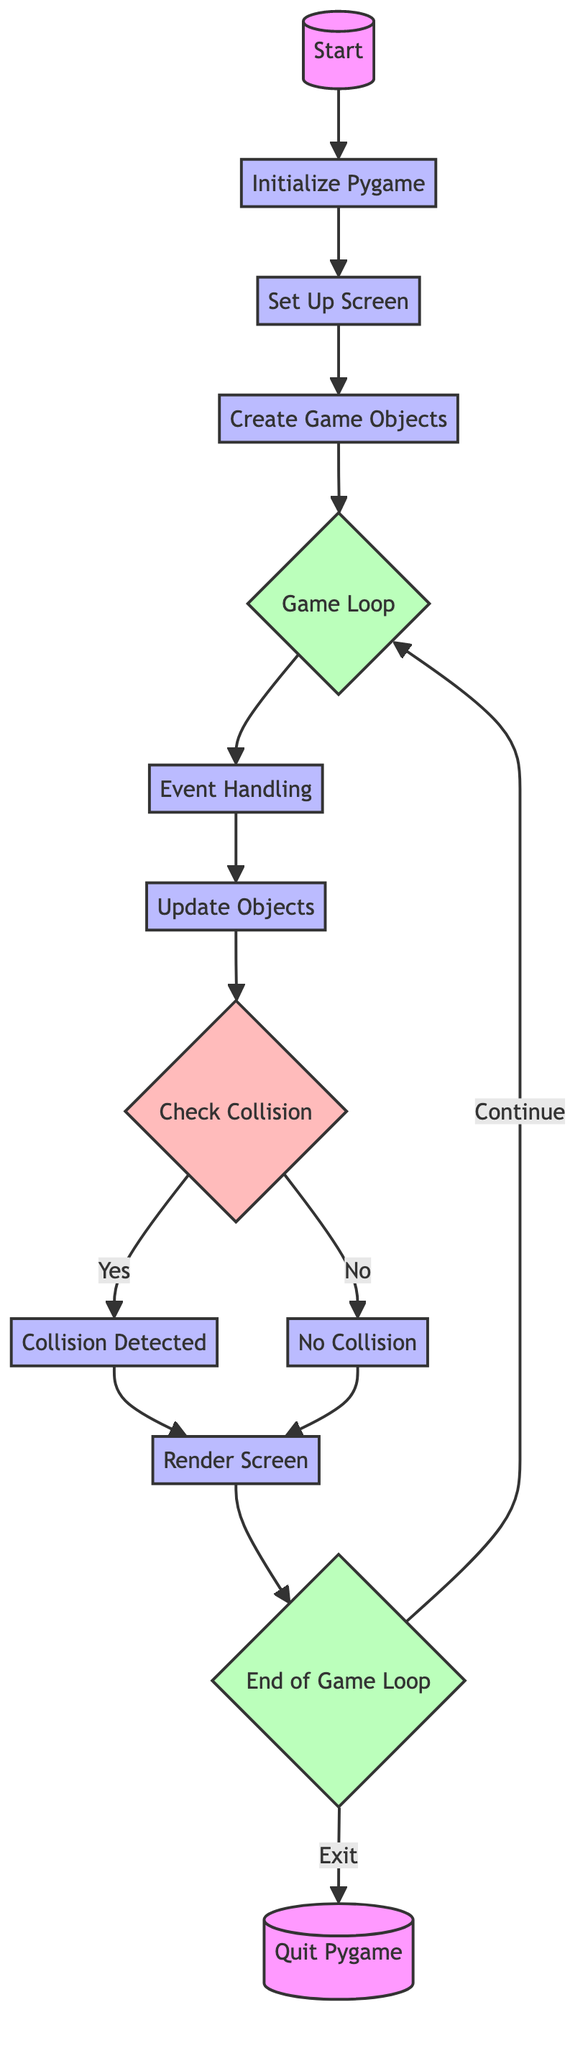What is the first step in the flow chart? The first step is labeled "Start" and describes initializing Pygame and setting up the screen. It is the entry point of the flowchart.
Answer: Start How many process nodes are in the diagram? By counting the nodes labeled with the type "process," we find there are six process nodes (initialize Pygame, set up screen, create game objects, event handling, update objects, render screen).
Answer: 6 What happens if "No Collision" is detected? If no collision is detected, the flow proceeds to the "Render Screen" node, continuing normal updates for positions and states of objects.
Answer: Continue updating positions and states normally What is the relationship between "Check Collision" and "Collision Detected"? "Check Collision" is a decision node that leads to "Collision Detected" if a collision is confirmed (yes), indicating a direct relationship based on the outcome of the check.
Answer: Decision-leading process What is the last step in the flow chart? The last step is labeled "Quit Pygame," which indicates the end of the process, occurring when the game is exited.
Answer: Quit Pygame How is the game loop structured in the flow chart? The game loop is shown as a circular process, indicated by the "Game Loop" and "End of Game Loop" nodes, cycling back to the "Game Loop" for continuous execution until exit.
Answer: Circular process structure What happens immediately after "Render Screen"? Immediately after rendering the screen, the flow transitions to the "End of Game Loop," where it checks if the game is still running.
Answer: Transition to "End of Game Loop" What condition leads to the execution of "Quit Pygame"? The condition that leads to "Quit Pygame" is marked as "on_exit," indicating that the game ends when this condition is met.
Answer: on_exit 